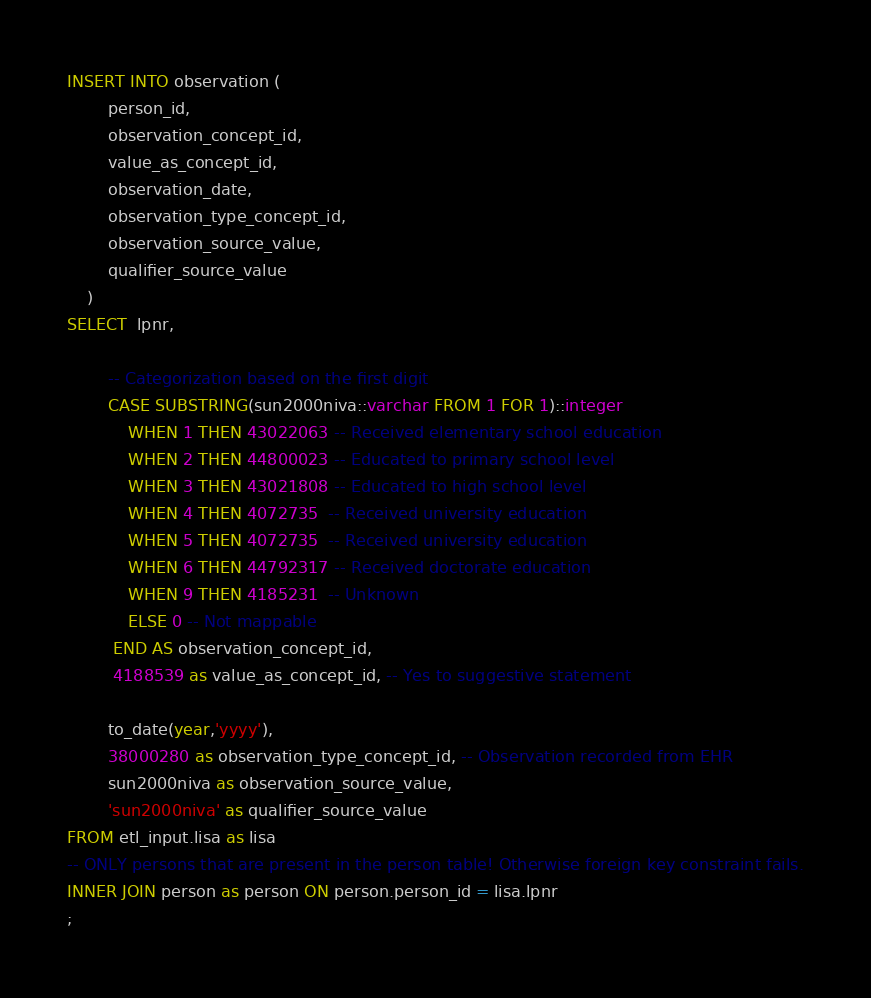<code> <loc_0><loc_0><loc_500><loc_500><_SQL_>INSERT INTO observation (
        person_id,
        observation_concept_id,
        value_as_concept_id,
        observation_date,
        observation_type_concept_id,
        observation_source_value,
        qualifier_source_value
    )
SELECT  lpnr,

        -- Categorization based on the first digit
        CASE SUBSTRING(sun2000niva::varchar FROM 1 FOR 1)::integer
            WHEN 1 THEN 43022063 -- Received elementary school education
            WHEN 2 THEN 44800023 -- Educated to primary school level
            WHEN 3 THEN 43021808 -- Educated to high school level
            WHEN 4 THEN 4072735  -- Received university education
            WHEN 5 THEN 4072735  -- Received university education
            WHEN 6 THEN 44792317 -- Received doctorate education
            WHEN 9 THEN 4185231  -- Unknown
            ELSE 0 -- Not mappable
         END AS observation_concept_id,
         4188539 as value_as_concept_id, -- Yes to suggestive statement

        to_date(year,'yyyy'),
        38000280 as observation_type_concept_id, -- Observation recorded from EHR
        sun2000niva as observation_source_value,
        'sun2000niva' as qualifier_source_value
FROM etl_input.lisa as lisa
-- ONLY persons that are present in the person table! Otherwise foreign key constraint fails.
INNER JOIN person as person ON person.person_id = lisa.lpnr
;
</code> 